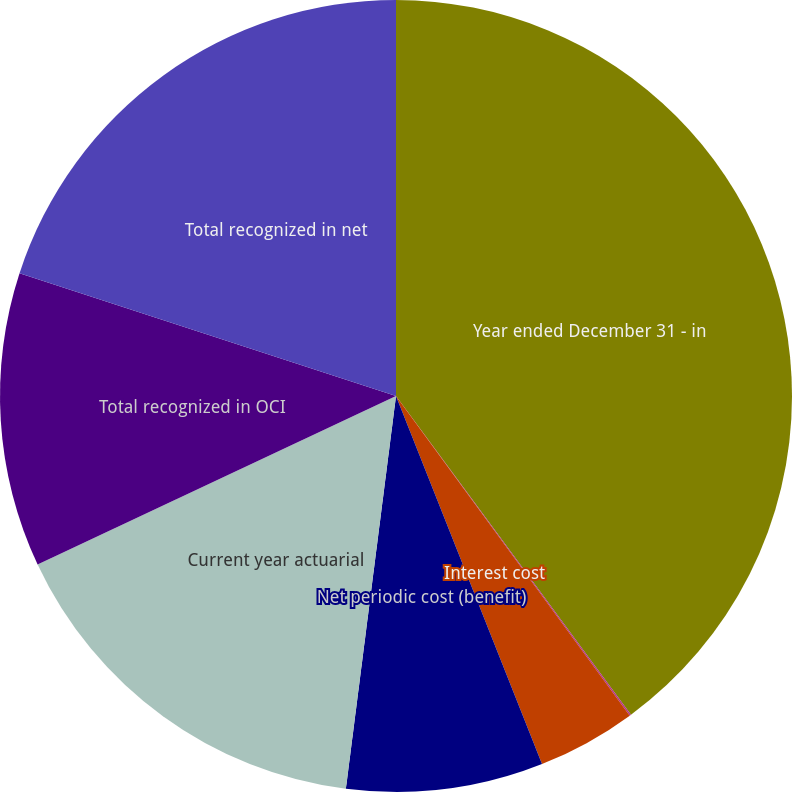Convert chart to OTSL. <chart><loc_0><loc_0><loc_500><loc_500><pie_chart><fcel>Year ended December 31 - in<fcel>Service cost<fcel>Interest cost<fcel>Net periodic cost (benefit)<fcel>Current year actuarial<fcel>Total recognized in OCI<fcel>Total recognized in net<nl><fcel>39.89%<fcel>0.06%<fcel>4.04%<fcel>8.03%<fcel>15.99%<fcel>12.01%<fcel>19.98%<nl></chart> 